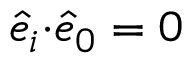Convert formula to latex. <formula><loc_0><loc_0><loc_500><loc_500>\hat { e } _ { i } { \cdot } \hat { e } _ { 0 } = 0</formula> 